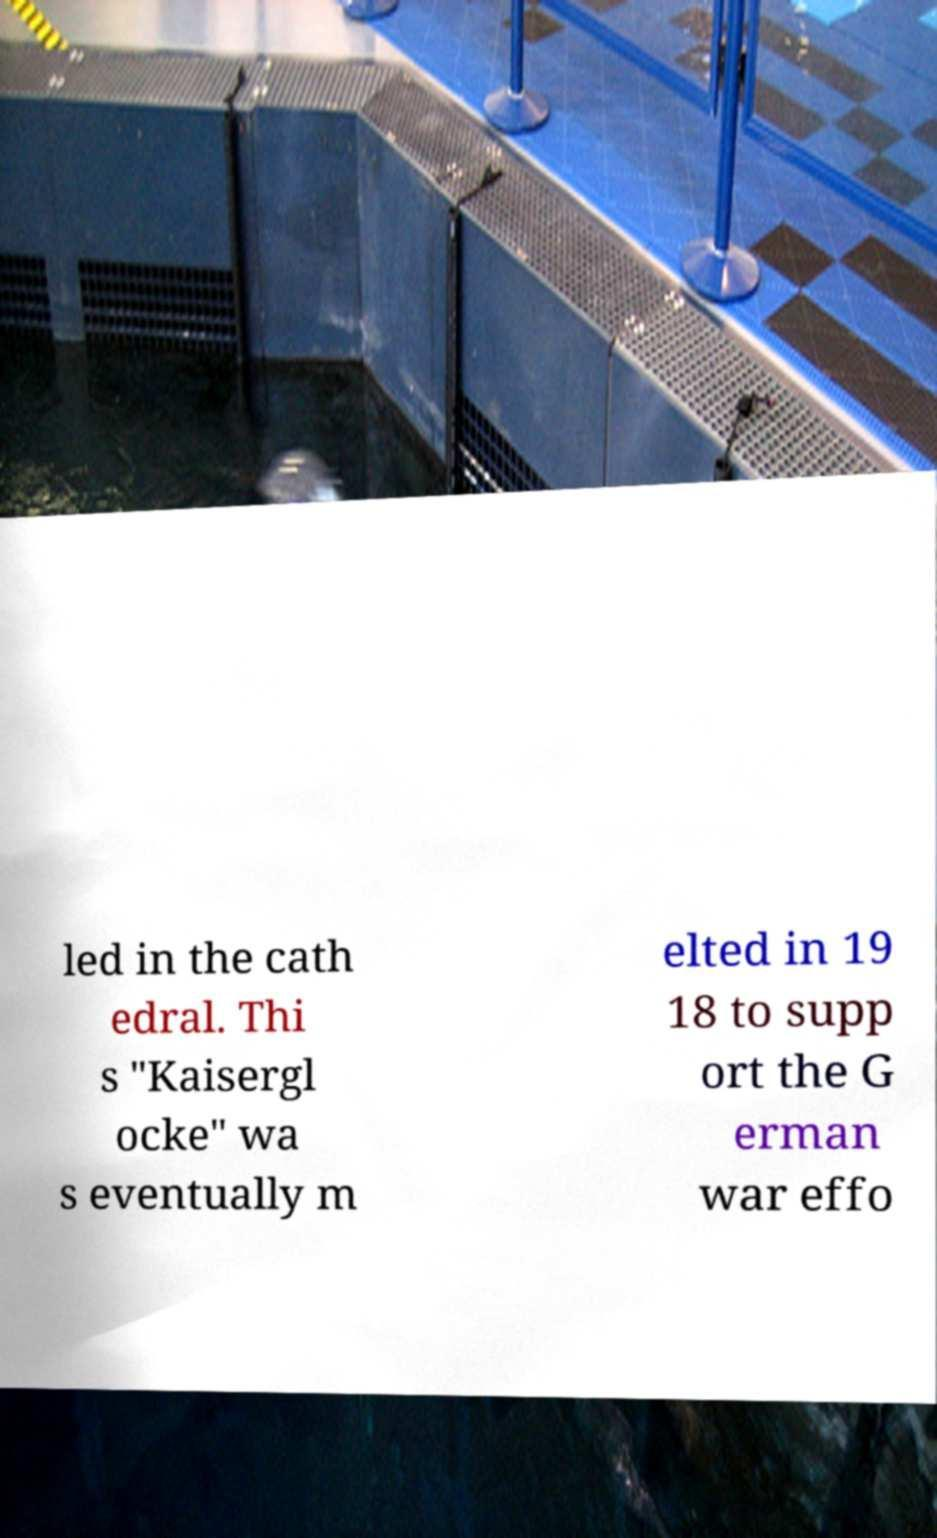Please read and relay the text visible in this image. What does it say? led in the cath edral. Thi s "Kaisergl ocke" wa s eventually m elted in 19 18 to supp ort the G erman war effo 